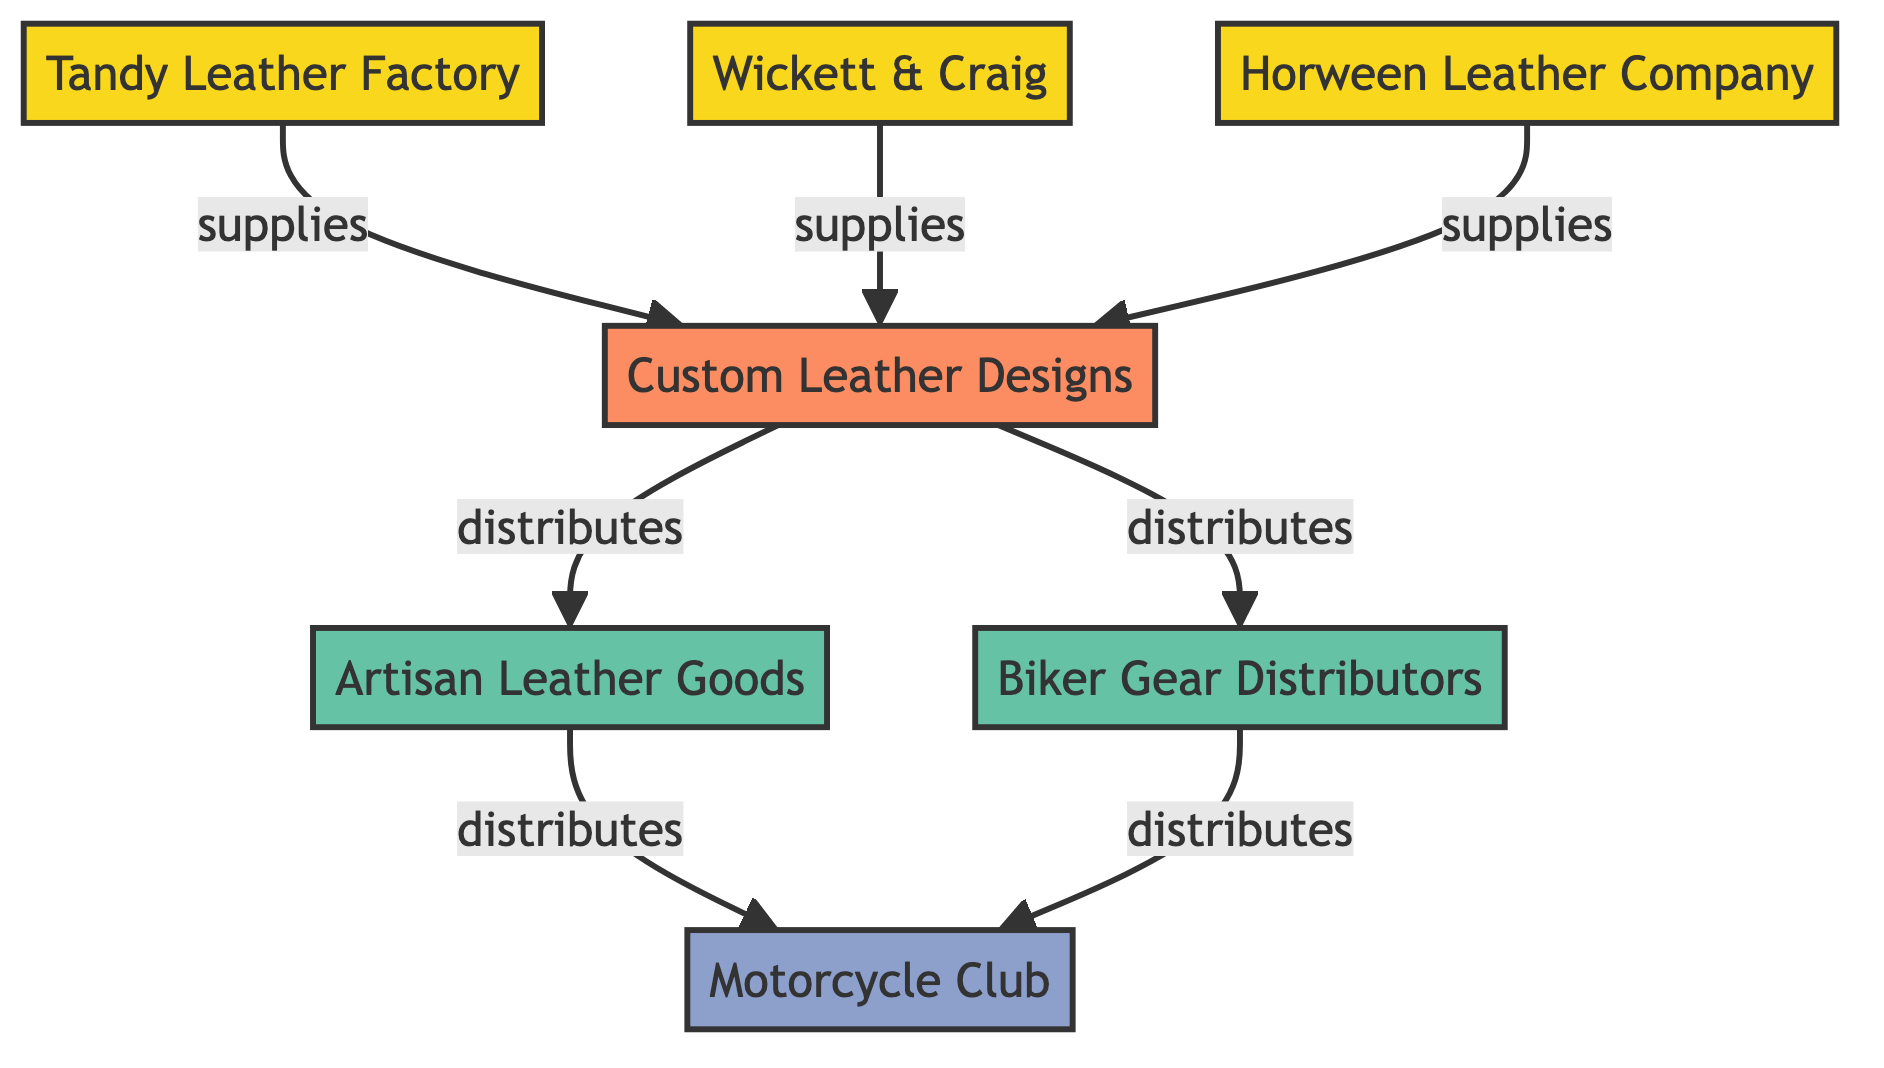What is the main category in the diagram? The main category is represented by a single node labeled "Custom Leather Designs." This can be identified by looking for the node type "main_category".
Answer: Custom Leather Designs How many suppliers are shown in the diagram? The diagram includes three nodes classified as suppliers: Tandy Leather Factory, Wickett & Craig, and Horween Leather Company. Counting these nodes gives us the total.
Answer: 3 Who distributes custom leather designs to the motorcycle club? The custom leather designs are distributed to the motorcycle club through two distributors: Artisan Leather Goods and Biker Gear Distributors. We can trace the edges leading from those distributors to the "Motorcycle Club" node.
Answer: Artisan Leather Goods, Biker Gear Distributors What type of relationship exists between the "Wickett & Craig" and "Custom Leather Designs" nodes? The relationship is one of supply, indicated by the edge labeled "supplies" connecting Wickett & Craig to Custom Leather Designs. The label on the connecting edge provides this information.
Answer: supplies How many edges are there in the diagram? There are six edges that connect the various nodes within the diagram. Each relationship shown can be counted to find this number.
Answer: 6 Which node is the end consumer in this network? The end consumer is represented by the node labeled "Motorcycle Club." This can be identified as the final node in the distribution path from the suppliers.
Answer: Motorcycle Club What does the "artisan_leather_goods" node do in this network? The artisan_leather_goods node has a distributing role, as indicated by the edge labeled "distributes" pointing towards the motorcycle club. This details its purpose within the network.
Answer: distributes Which supplier supplies to "Custom Leather Designs" along with "Tandy Leather Factory"? Alongside Tandy Leather Factory, both Wickett & Craig and Horween Leather Company also supply to Custom Leather Designs, as indicated by the multiple connecting edges labeled "supplies".
Answer: Wickett & Craig, Horween Leather Company 